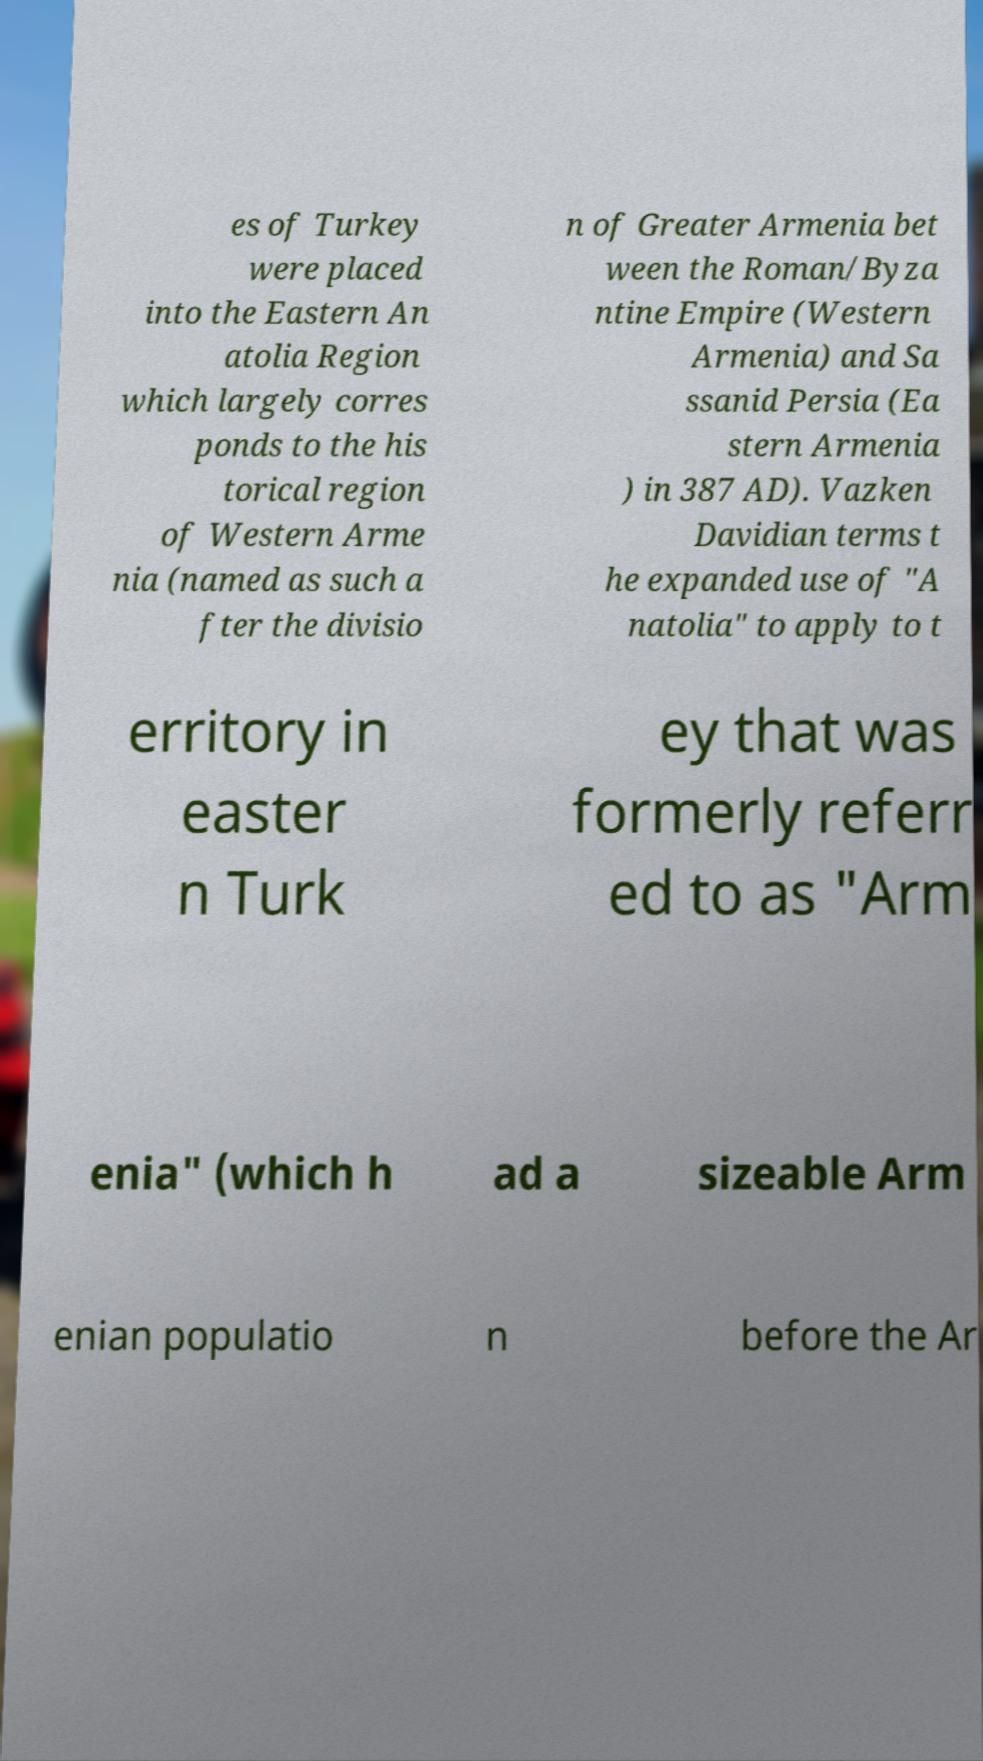Could you assist in decoding the text presented in this image and type it out clearly? es of Turkey were placed into the Eastern An atolia Region which largely corres ponds to the his torical region of Western Arme nia (named as such a fter the divisio n of Greater Armenia bet ween the Roman/Byza ntine Empire (Western Armenia) and Sa ssanid Persia (Ea stern Armenia ) in 387 AD). Vazken Davidian terms t he expanded use of "A natolia" to apply to t erritory in easter n Turk ey that was formerly referr ed to as "Arm enia" (which h ad a sizeable Arm enian populatio n before the Ar 